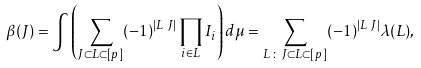Convert formula to latex. <formula><loc_0><loc_0><loc_500><loc_500>\beta ( J ) & = \int \left ( \sum _ { J \subset L \subset [ p ] } ( - 1 ) ^ { | L \ J | } \prod _ { i \in L } I _ { i } \right ) d \mu = \sum _ { L \, \colon \, J \subset L \subset [ p ] } ( - 1 ) ^ { | L \ J | } \lambda ( L ) ,</formula> 